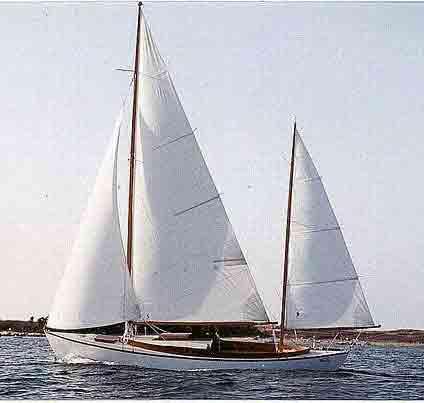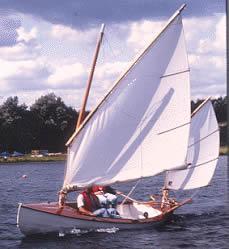The first image is the image on the left, the second image is the image on the right. Examine the images to the left and right. Is the description "The sailboat in the right image is tipped rightward, showing its interior." accurate? Answer yes or no. Yes. The first image is the image on the left, the second image is the image on the right. Analyze the images presented: Is the assertion "One boat only has two sails unfurled." valid? Answer yes or no. Yes. 